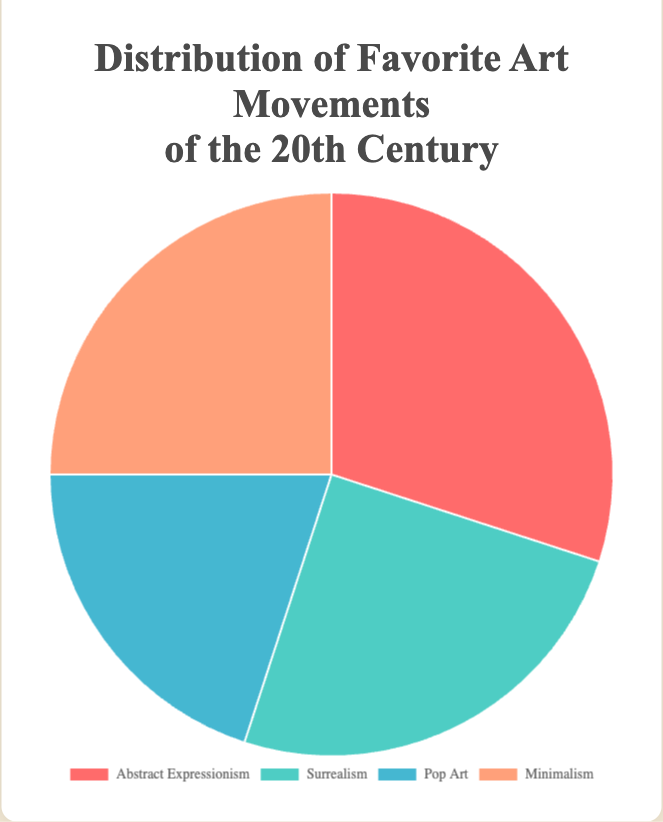Which art movement has the largest percentage of preference according to the pie chart? The chart's largest segment represents Abstract Expressionism, which has a 30% preference.
Answer: Abstract Expressionism What is the combined percentage of people who prefer Surrealism and Minimalism? Surrealism has 25% and Minimalism also has 25%. Adding these together, 25% + 25% = 50%.
Answer: 50% Which two art movements are equally preferred based on the chart? Both Surrealism and Minimalism have the same percentage of 25%.
Answer: Surrealism and Minimalism How much greater is the preference for Abstract Expressionism compared to Pop Art? Abstract Expressionism is preferred by 30%, whereas Pop Art has 20%. The difference is 30% - 20% = 10%.
Answer: 10% What percentage of people do not prefer Abstract Expressionism? Since Abstract Expressionism has 30%, the remaining percentage is 100% - 30% = 70%.
Answer: 70% Which color represents Pop Art on the pie chart? The pie chart's legend shows that Pop Art is represented by a blue color section.
Answer: Blue Is Abstract Expressionism preferred by more people than Surrealism? Abstract Expressionism has 30% while Surrealism has 25%. Comparing these, 30% > 25%.
Answer: Yes If we combine the percentages of Pop Art and Surrealism, will it exceed the preference for Abstract Expressionism? Pop Art has 20% and Surrealism has 25%. Together, 20% + 25% = 45%. Since 45% > 30%, their combined preference does exceed Abstract Expressionism.
Answer: Yes What is the least preferred art movement in the pie chart? The pie chart shows that Pop Art has the smallest percentage of preference at 20%.
Answer: Pop Art 